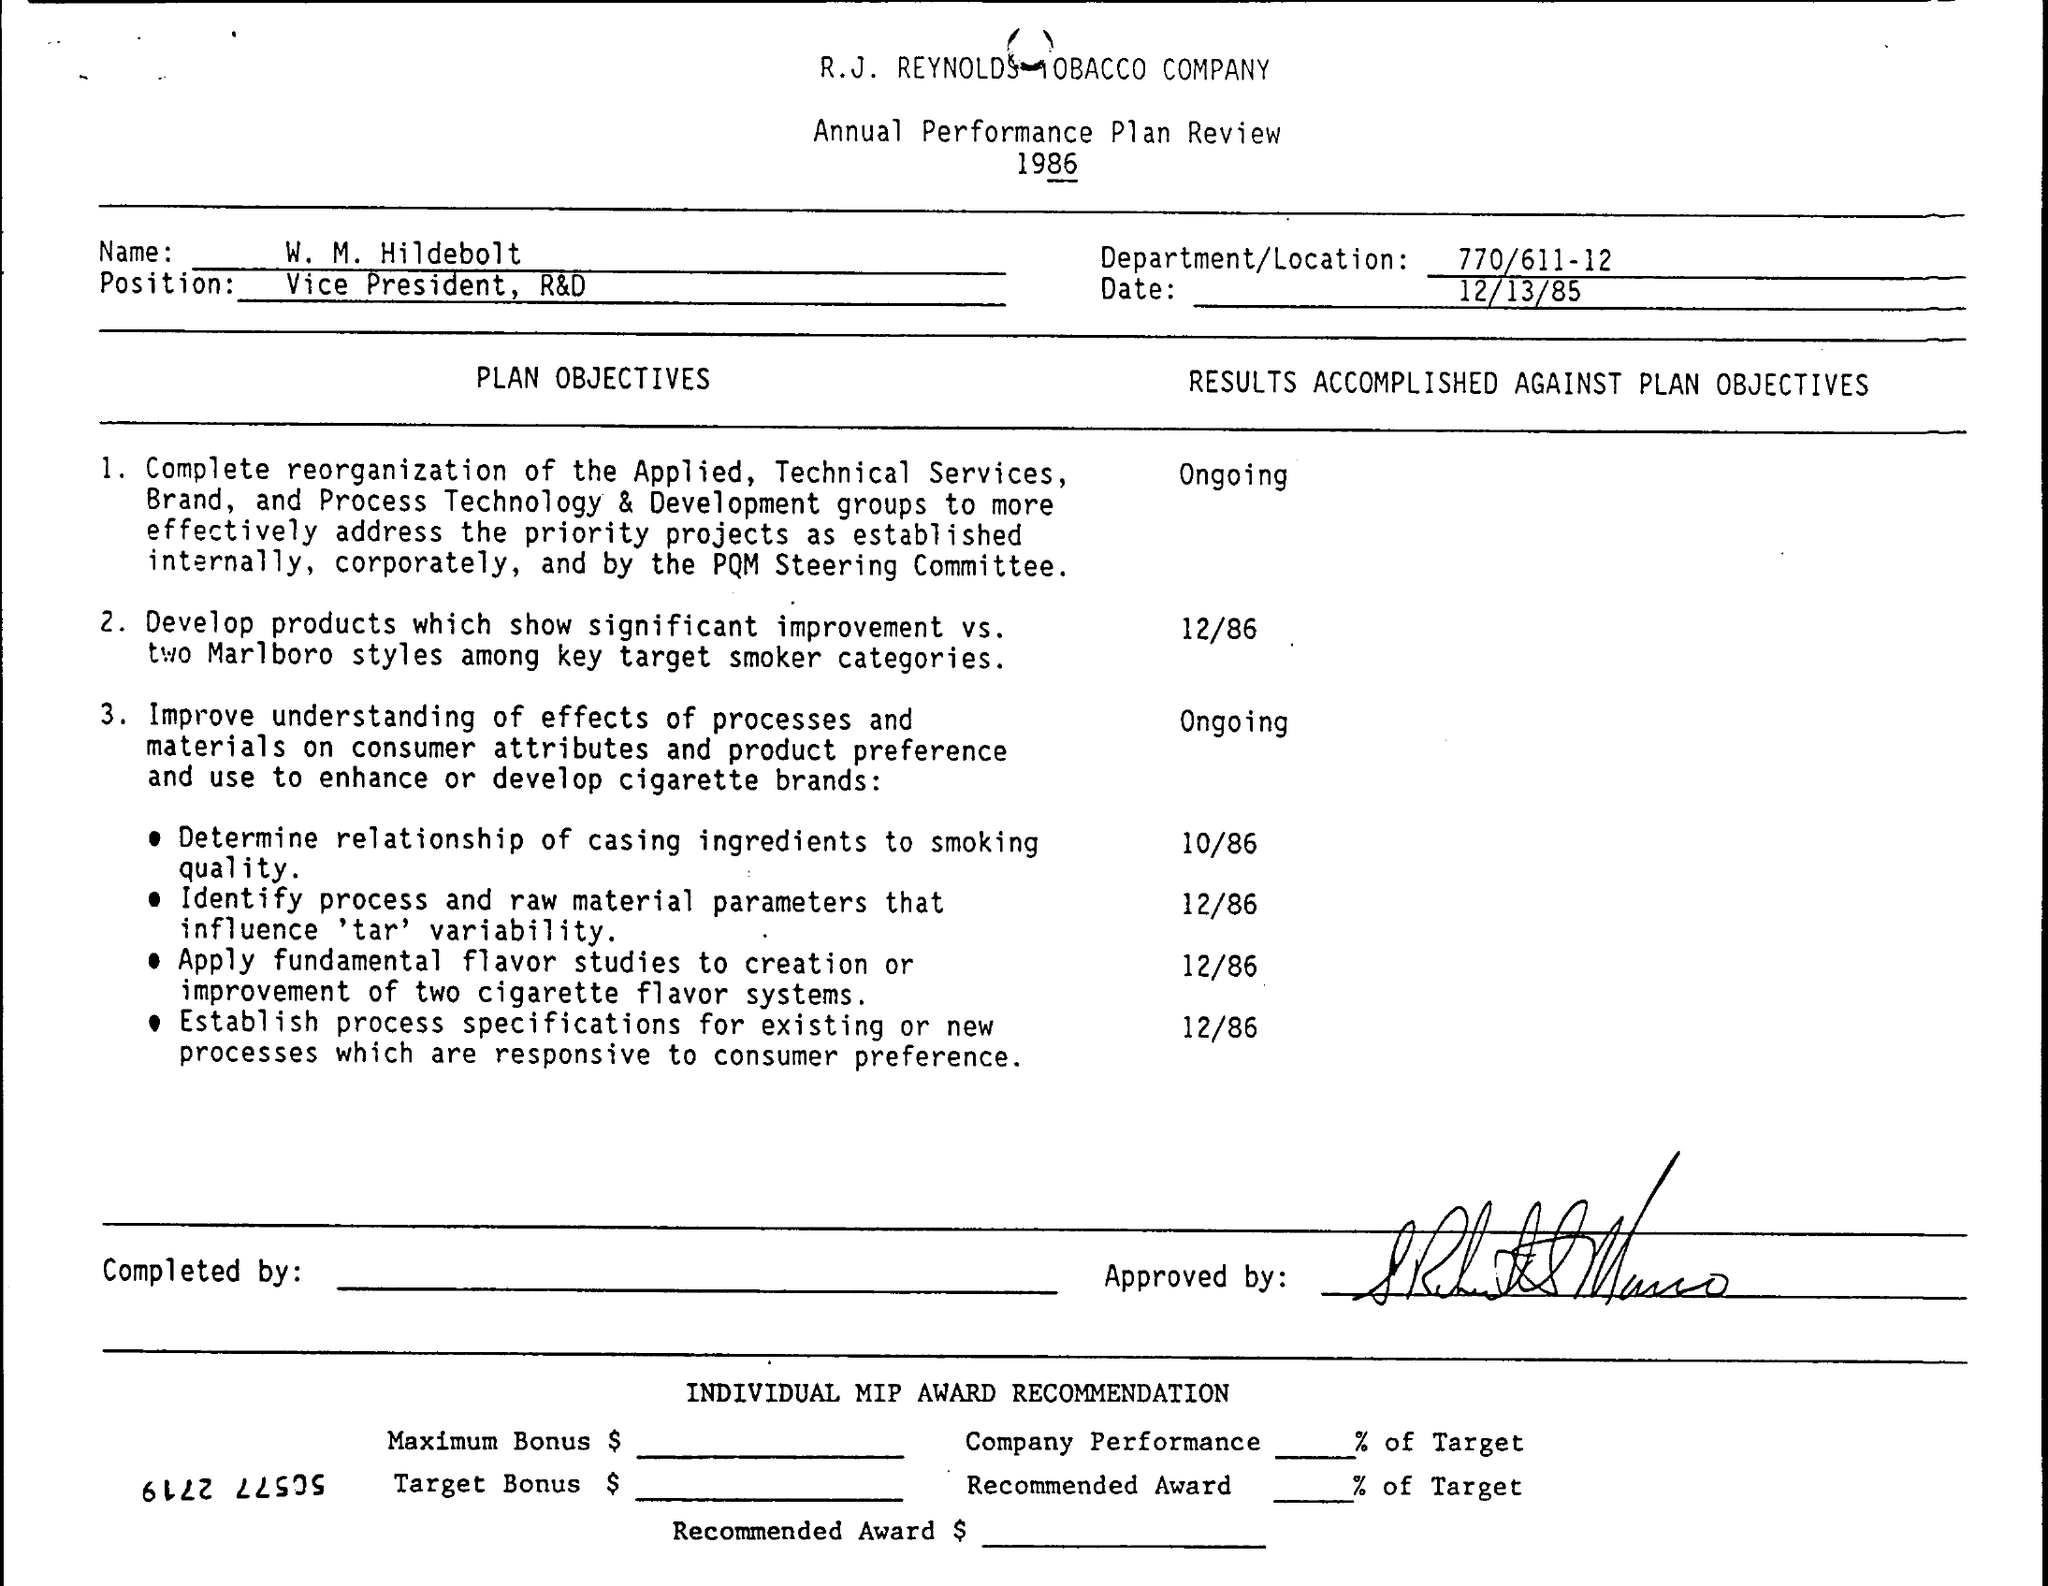Specify some key components in this picture. This document is from the year 1986. The date mentioned is 12/13/85. 